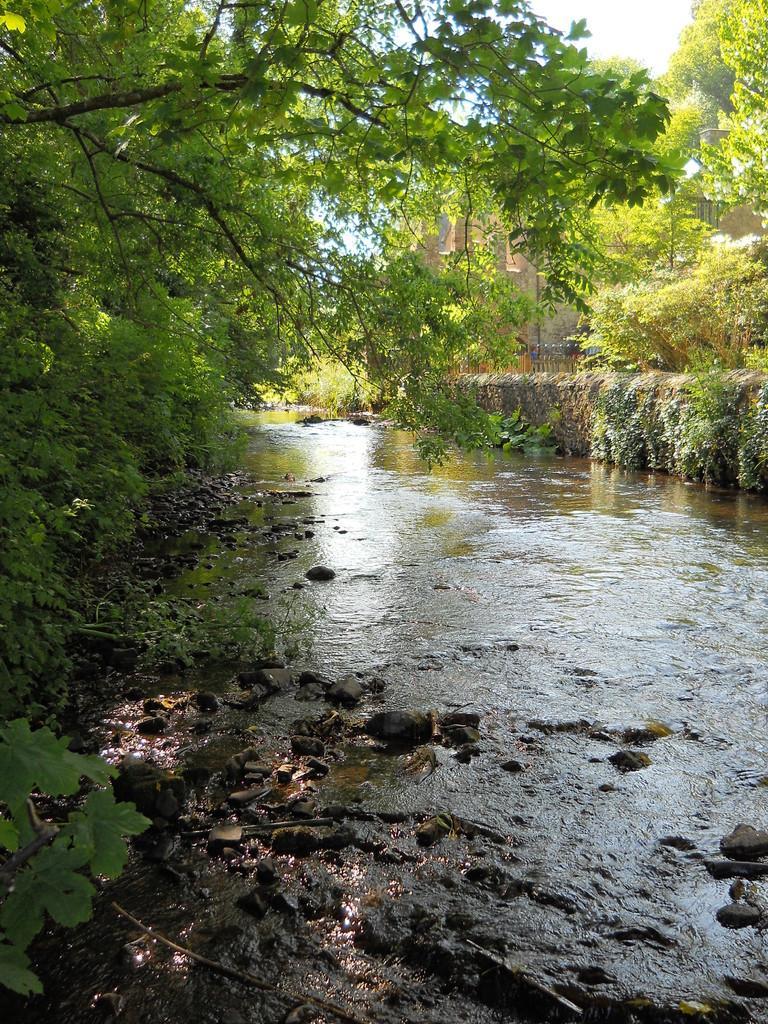How would you summarize this image in a sentence or two? In this picture we can see one lake, beside some trees and one building. 